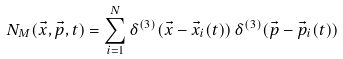Convert formula to latex. <formula><loc_0><loc_0><loc_500><loc_500>N _ { M } ( \vec { x } , \vec { p } , t ) = \sum _ { i = 1 } ^ { N } \delta ^ { ( 3 ) } ( \vec { x } - \vec { x } _ { i } ( t ) ) \, \delta ^ { ( 3 ) } ( \vec { p } - \vec { p } _ { i } ( t ) )</formula> 